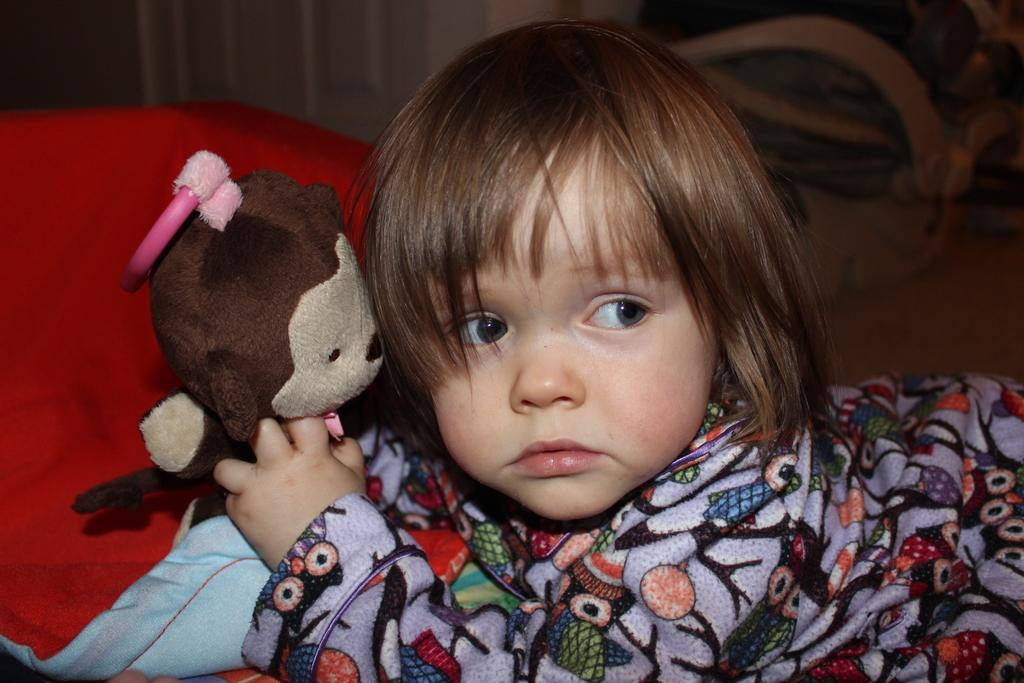What is the main subject of the image? There is a baby in the image. Where is the baby located? The baby is lying on a bed. What is the baby holding in the image? The baby is holding a toy. What color is the pillow on the bed? There is a red color pillow on the bed. What can be seen behind the baby? There is a wall behind the baby. How many boys are participating in the class in the image? There is no class or boys present in the image; it features a baby lying on a bed holding a toy. 